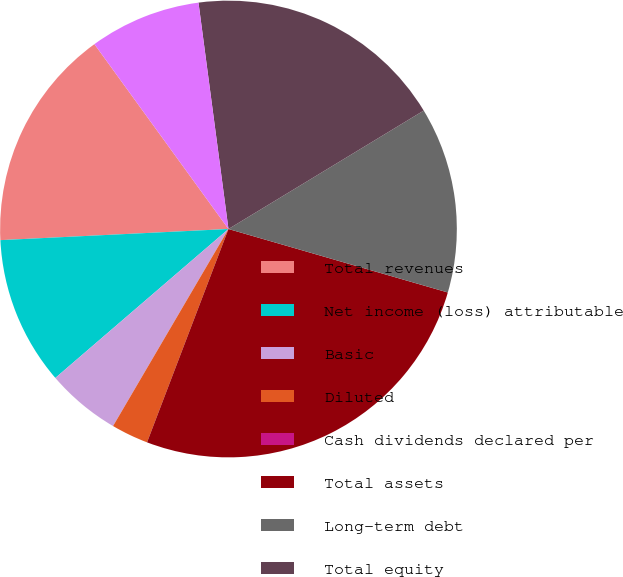Convert chart. <chart><loc_0><loc_0><loc_500><loc_500><pie_chart><fcel>Total revenues<fcel>Net income (loss) attributable<fcel>Basic<fcel>Diluted<fcel>Cash dividends declared per<fcel>Total assets<fcel>Long-term debt<fcel>Total equity<fcel>Common shares outstanding<nl><fcel>15.79%<fcel>10.53%<fcel>5.26%<fcel>2.63%<fcel>0.0%<fcel>26.32%<fcel>13.16%<fcel>18.42%<fcel>7.89%<nl></chart> 